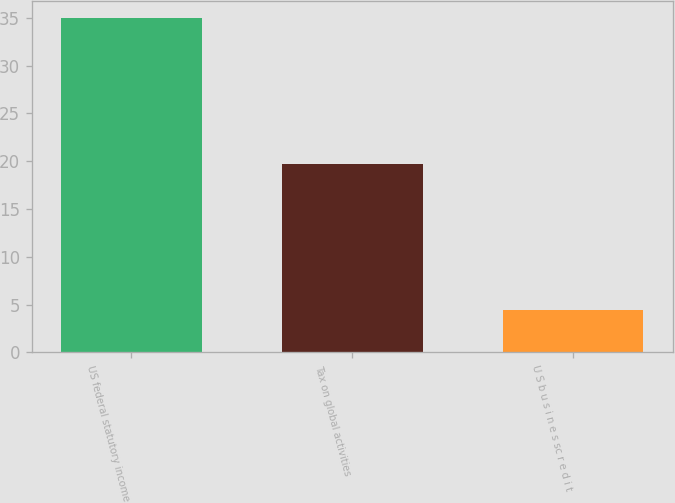Convert chart to OTSL. <chart><loc_0><loc_0><loc_500><loc_500><bar_chart><fcel>US federal statutory income<fcel>Tax on global activities<fcel>U S b u s i n e s sc r e d i t<nl><fcel>35<fcel>19.7<fcel>4.4<nl></chart> 